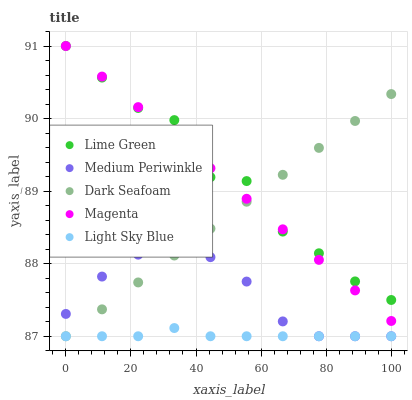Does Light Sky Blue have the minimum area under the curve?
Answer yes or no. Yes. Does Lime Green have the maximum area under the curve?
Answer yes or no. Yes. Does Dark Seafoam have the minimum area under the curve?
Answer yes or no. No. Does Dark Seafoam have the maximum area under the curve?
Answer yes or no. No. Is Dark Seafoam the smoothest?
Answer yes or no. Yes. Is Lime Green the roughest?
Answer yes or no. Yes. Is Light Sky Blue the smoothest?
Answer yes or no. No. Is Light Sky Blue the roughest?
Answer yes or no. No. Does Medium Periwinkle have the lowest value?
Answer yes or no. Yes. Does Lime Green have the lowest value?
Answer yes or no. No. Does Magenta have the highest value?
Answer yes or no. Yes. Does Dark Seafoam have the highest value?
Answer yes or no. No. Is Light Sky Blue less than Magenta?
Answer yes or no. Yes. Is Lime Green greater than Light Sky Blue?
Answer yes or no. Yes. Does Dark Seafoam intersect Light Sky Blue?
Answer yes or no. Yes. Is Dark Seafoam less than Light Sky Blue?
Answer yes or no. No. Is Dark Seafoam greater than Light Sky Blue?
Answer yes or no. No. Does Light Sky Blue intersect Magenta?
Answer yes or no. No. 